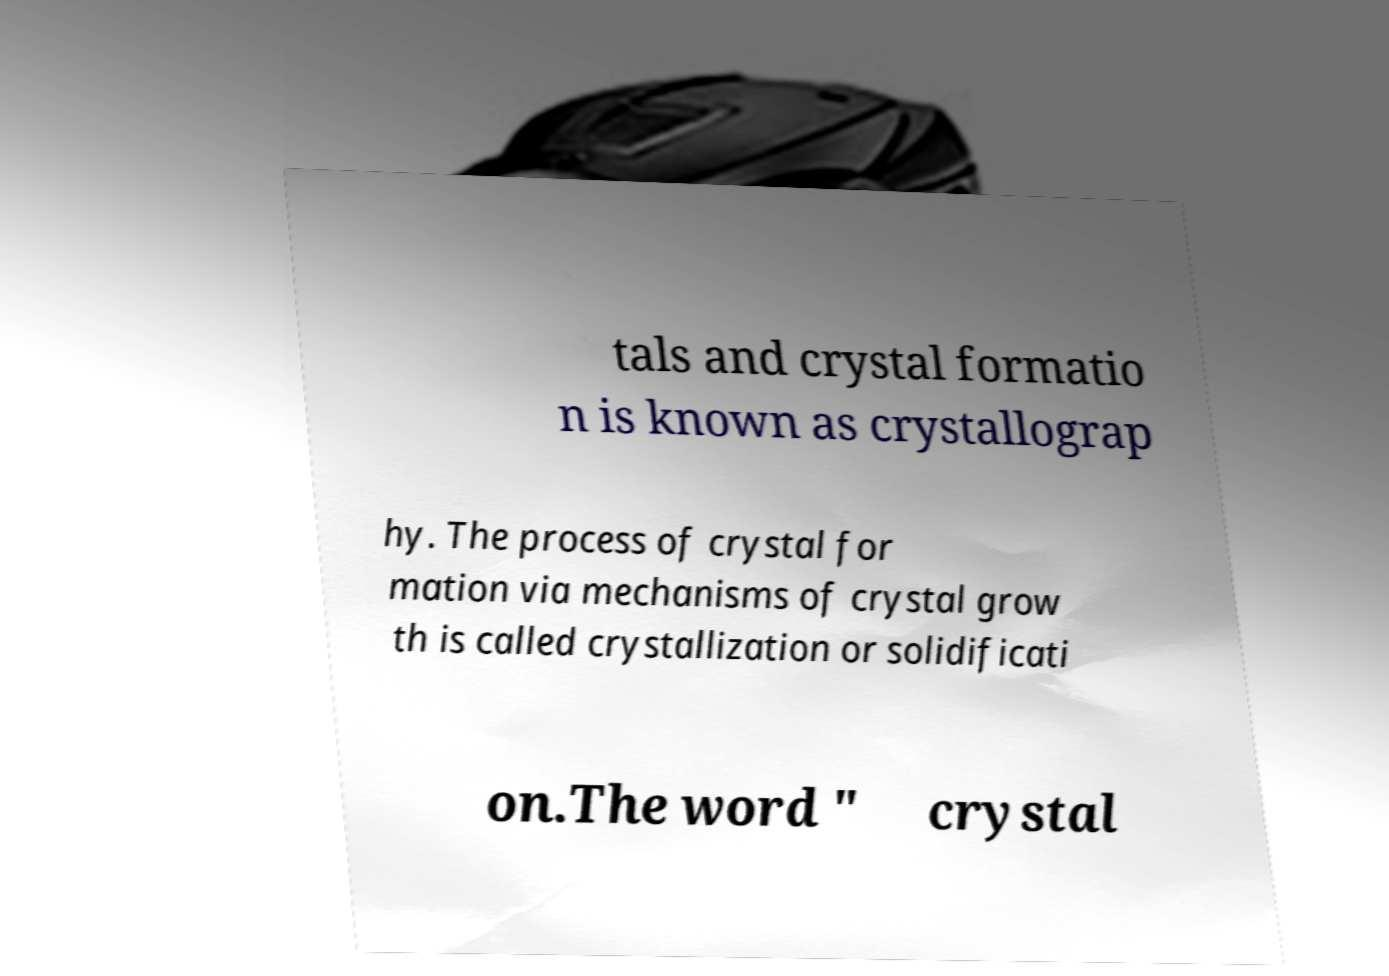Can you accurately transcribe the text from the provided image for me? tals and crystal formatio n is known as crystallograp hy. The process of crystal for mation via mechanisms of crystal grow th is called crystallization or solidificati on.The word " crystal 